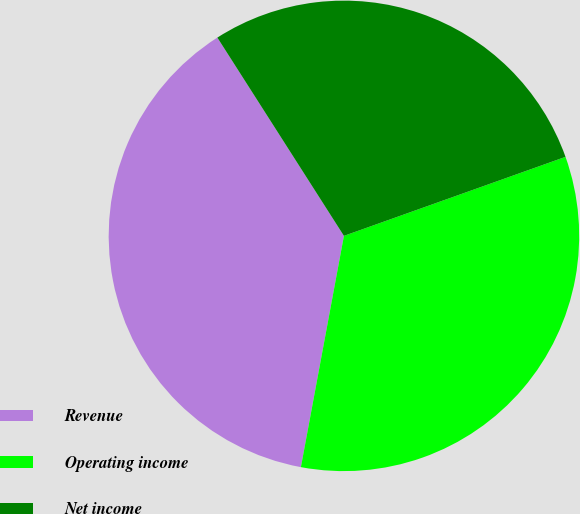Convert chart. <chart><loc_0><loc_0><loc_500><loc_500><pie_chart><fcel>Revenue<fcel>Operating income<fcel>Net income<nl><fcel>38.03%<fcel>33.38%<fcel>28.59%<nl></chart> 